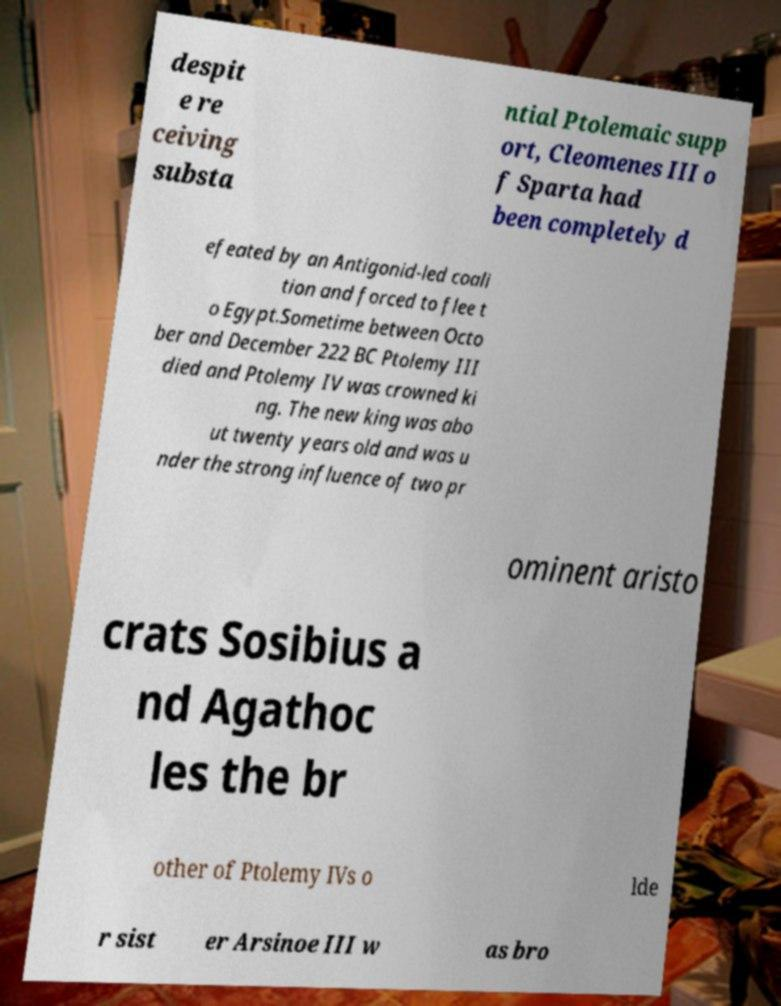Could you assist in decoding the text presented in this image and type it out clearly? despit e re ceiving substa ntial Ptolemaic supp ort, Cleomenes III o f Sparta had been completely d efeated by an Antigonid-led coali tion and forced to flee t o Egypt.Sometime between Octo ber and December 222 BC Ptolemy III died and Ptolemy IV was crowned ki ng. The new king was abo ut twenty years old and was u nder the strong influence of two pr ominent aristo crats Sosibius a nd Agathoc les the br other of Ptolemy IVs o lde r sist er Arsinoe III w as bro 